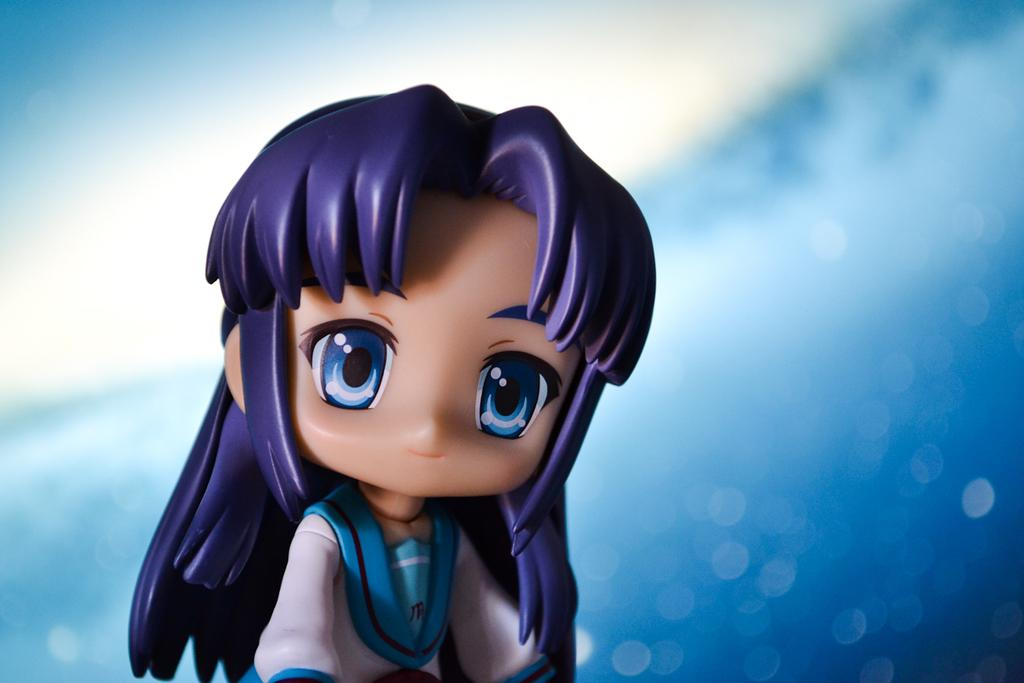What object can be seen in the image? There is a toy in the image. Can you describe the background of the image? The background of the image is white and blue. How many people are in the crowd surrounding the toy in the image? There is no crowd present in the image; it only features a toy and a white and blue background. 